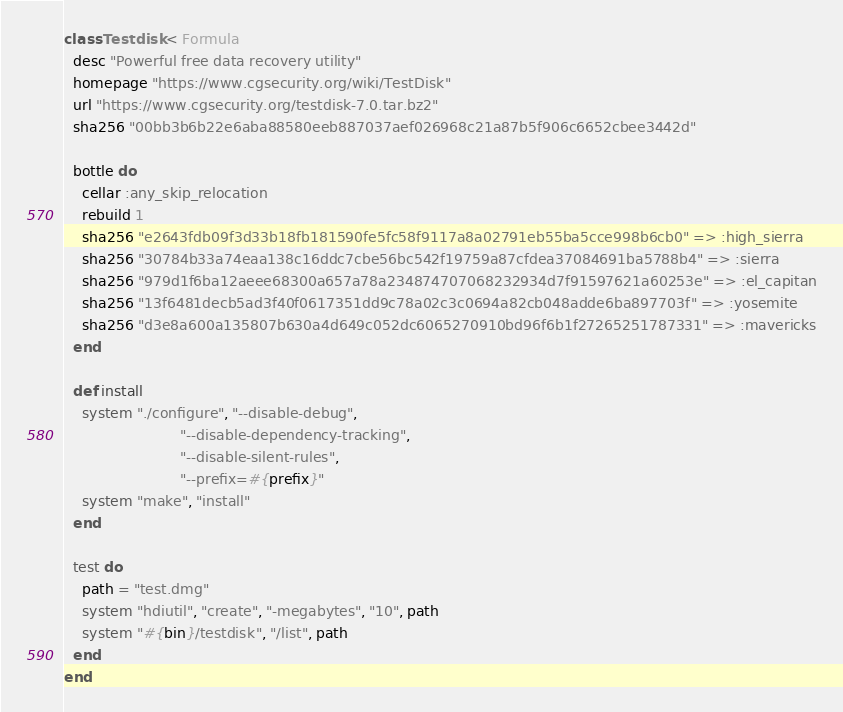Convert code to text. <code><loc_0><loc_0><loc_500><loc_500><_Ruby_>class Testdisk < Formula
  desc "Powerful free data recovery utility"
  homepage "https://www.cgsecurity.org/wiki/TestDisk"
  url "https://www.cgsecurity.org/testdisk-7.0.tar.bz2"
  sha256 "00bb3b6b22e6aba88580eeb887037aef026968c21a87b5f906c6652cbee3442d"

  bottle do
    cellar :any_skip_relocation
    rebuild 1
    sha256 "e2643fdb09f3d33b18fb181590fe5fc58f9117a8a02791eb55ba5cce998b6cb0" => :high_sierra
    sha256 "30784b33a74eaa138c16ddc7cbe56bc542f19759a87cfdea37084691ba5788b4" => :sierra
    sha256 "979d1f6ba12aeee68300a657a78a234874707068232934d7f91597621a60253e" => :el_capitan
    sha256 "13f6481decb5ad3f40f0617351dd9c78a02c3c0694a82cb048adde6ba897703f" => :yosemite
    sha256 "d3e8a600a135807b630a4d649c052dc6065270910bd96f6b1f27265251787331" => :mavericks
  end

  def install
    system "./configure", "--disable-debug",
                          "--disable-dependency-tracking",
                          "--disable-silent-rules",
                          "--prefix=#{prefix}"
    system "make", "install"
  end

  test do
    path = "test.dmg"
    system "hdiutil", "create", "-megabytes", "10", path
    system "#{bin}/testdisk", "/list", path
  end
end
</code> 